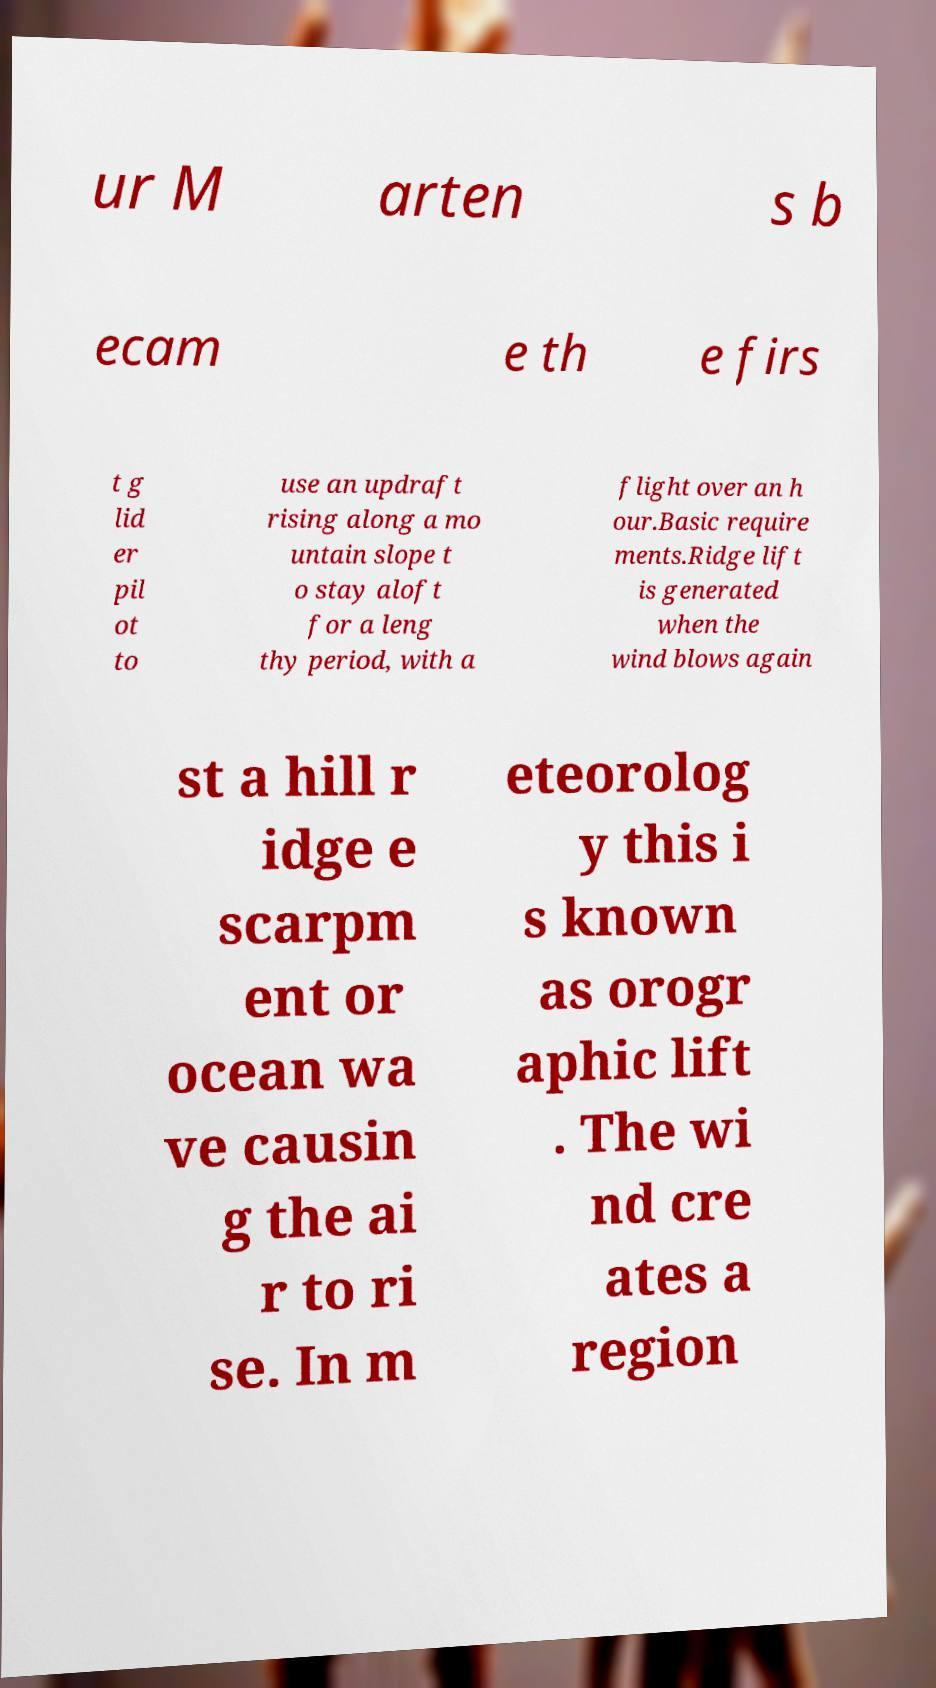Can you read and provide the text displayed in the image?This photo seems to have some interesting text. Can you extract and type it out for me? ur M arten s b ecam e th e firs t g lid er pil ot to use an updraft rising along a mo untain slope t o stay aloft for a leng thy period, with a flight over an h our.Basic require ments.Ridge lift is generated when the wind blows again st a hill r idge e scarpm ent or ocean wa ve causin g the ai r to ri se. In m eteorolog y this i s known as orogr aphic lift . The wi nd cre ates a region 